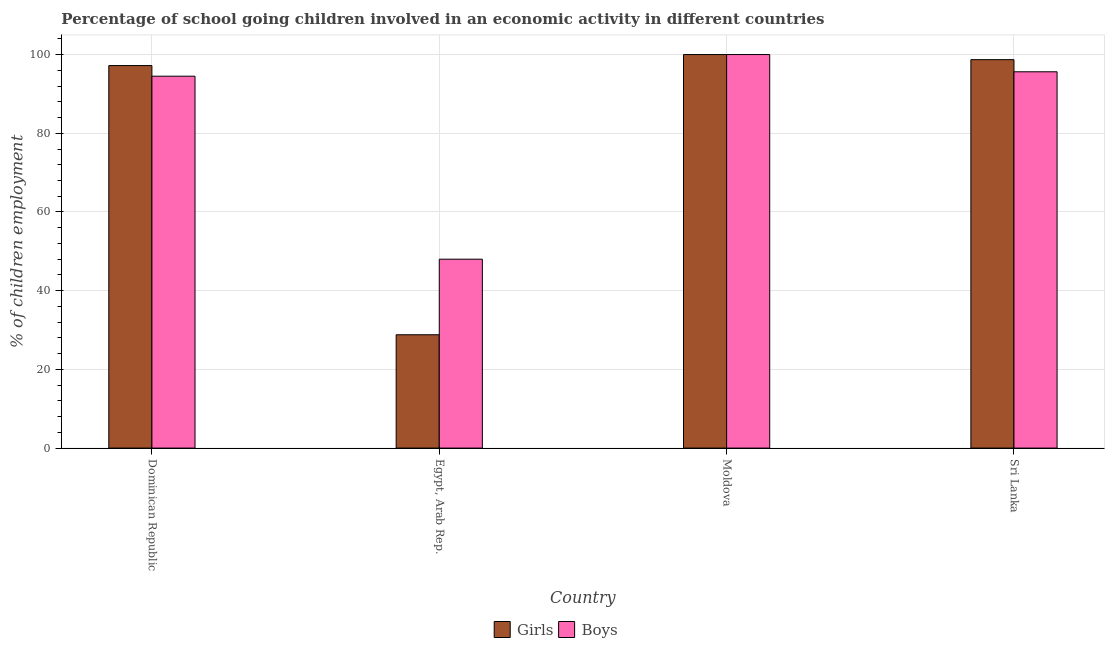How many different coloured bars are there?
Offer a very short reply. 2. How many bars are there on the 2nd tick from the left?
Offer a terse response. 2. What is the label of the 1st group of bars from the left?
Offer a terse response. Dominican Republic. Across all countries, what is the maximum percentage of school going boys?
Provide a short and direct response. 100. In which country was the percentage of school going boys maximum?
Your answer should be very brief. Moldova. In which country was the percentage of school going boys minimum?
Give a very brief answer. Egypt, Arab Rep. What is the total percentage of school going boys in the graph?
Your response must be concise. 338.12. What is the difference between the percentage of school going boys in Egypt, Arab Rep. and that in Sri Lanka?
Give a very brief answer. -47.62. What is the difference between the percentage of school going boys in Sri Lanka and the percentage of school going girls in Dominican Republic?
Make the answer very short. -1.58. What is the average percentage of school going girls per country?
Provide a succinct answer. 81.18. What is the difference between the percentage of school going girls and percentage of school going boys in Sri Lanka?
Ensure brevity in your answer.  3.08. In how many countries, is the percentage of school going boys greater than 4 %?
Ensure brevity in your answer.  4. What is the ratio of the percentage of school going girls in Dominican Republic to that in Moldova?
Provide a short and direct response. 0.97. What is the difference between the highest and the second highest percentage of school going girls?
Offer a terse response. 1.29. What is the difference between the highest and the lowest percentage of school going girls?
Keep it short and to the point. 71.2. Is the sum of the percentage of school going boys in Moldova and Sri Lanka greater than the maximum percentage of school going girls across all countries?
Your answer should be compact. Yes. What does the 1st bar from the left in Egypt, Arab Rep. represents?
Ensure brevity in your answer.  Girls. What does the 1st bar from the right in Dominican Republic represents?
Ensure brevity in your answer.  Boys. Are all the bars in the graph horizontal?
Offer a very short reply. No. How are the legend labels stacked?
Provide a short and direct response. Horizontal. What is the title of the graph?
Your answer should be very brief. Percentage of school going children involved in an economic activity in different countries. What is the label or title of the Y-axis?
Make the answer very short. % of children employment. What is the % of children employment of Girls in Dominican Republic?
Keep it short and to the point. 97.2. What is the % of children employment in Boys in Dominican Republic?
Your answer should be very brief. 94.5. What is the % of children employment of Girls in Egypt, Arab Rep.?
Keep it short and to the point. 28.8. What is the % of children employment in Boys in Egypt, Arab Rep.?
Ensure brevity in your answer.  48. What is the % of children employment in Girls in Sri Lanka?
Provide a short and direct response. 98.71. What is the % of children employment in Boys in Sri Lanka?
Give a very brief answer. 95.62. Across all countries, what is the minimum % of children employment in Girls?
Keep it short and to the point. 28.8. Across all countries, what is the minimum % of children employment in Boys?
Make the answer very short. 48. What is the total % of children employment of Girls in the graph?
Your answer should be very brief. 324.7. What is the total % of children employment of Boys in the graph?
Your response must be concise. 338.12. What is the difference between the % of children employment of Girls in Dominican Republic and that in Egypt, Arab Rep.?
Provide a succinct answer. 68.4. What is the difference between the % of children employment in Boys in Dominican Republic and that in Egypt, Arab Rep.?
Offer a very short reply. 46.5. What is the difference between the % of children employment in Girls in Dominican Republic and that in Moldova?
Give a very brief answer. -2.8. What is the difference between the % of children employment of Girls in Dominican Republic and that in Sri Lanka?
Your response must be concise. -1.5. What is the difference between the % of children employment of Boys in Dominican Republic and that in Sri Lanka?
Provide a short and direct response. -1.12. What is the difference between the % of children employment of Girls in Egypt, Arab Rep. and that in Moldova?
Provide a short and direct response. -71.2. What is the difference between the % of children employment of Boys in Egypt, Arab Rep. and that in Moldova?
Offer a terse response. -52. What is the difference between the % of children employment of Girls in Egypt, Arab Rep. and that in Sri Lanka?
Your answer should be compact. -69.91. What is the difference between the % of children employment of Boys in Egypt, Arab Rep. and that in Sri Lanka?
Ensure brevity in your answer.  -47.62. What is the difference between the % of children employment of Girls in Moldova and that in Sri Lanka?
Give a very brief answer. 1.29. What is the difference between the % of children employment in Boys in Moldova and that in Sri Lanka?
Provide a succinct answer. 4.38. What is the difference between the % of children employment of Girls in Dominican Republic and the % of children employment of Boys in Egypt, Arab Rep.?
Your answer should be very brief. 49.2. What is the difference between the % of children employment in Girls in Dominican Republic and the % of children employment in Boys in Moldova?
Your answer should be compact. -2.8. What is the difference between the % of children employment in Girls in Dominican Republic and the % of children employment in Boys in Sri Lanka?
Offer a terse response. 1.58. What is the difference between the % of children employment in Girls in Egypt, Arab Rep. and the % of children employment in Boys in Moldova?
Give a very brief answer. -71.2. What is the difference between the % of children employment of Girls in Egypt, Arab Rep. and the % of children employment of Boys in Sri Lanka?
Offer a very short reply. -66.82. What is the difference between the % of children employment in Girls in Moldova and the % of children employment in Boys in Sri Lanka?
Make the answer very short. 4.38. What is the average % of children employment of Girls per country?
Provide a succinct answer. 81.18. What is the average % of children employment of Boys per country?
Provide a short and direct response. 84.53. What is the difference between the % of children employment of Girls and % of children employment of Boys in Dominican Republic?
Provide a succinct answer. 2.7. What is the difference between the % of children employment of Girls and % of children employment of Boys in Egypt, Arab Rep.?
Ensure brevity in your answer.  -19.2. What is the difference between the % of children employment in Girls and % of children employment in Boys in Moldova?
Give a very brief answer. 0. What is the difference between the % of children employment of Girls and % of children employment of Boys in Sri Lanka?
Your response must be concise. 3.08. What is the ratio of the % of children employment of Girls in Dominican Republic to that in Egypt, Arab Rep.?
Your answer should be compact. 3.38. What is the ratio of the % of children employment of Boys in Dominican Republic to that in Egypt, Arab Rep.?
Offer a terse response. 1.97. What is the ratio of the % of children employment in Boys in Dominican Republic to that in Moldova?
Make the answer very short. 0.94. What is the ratio of the % of children employment of Boys in Dominican Republic to that in Sri Lanka?
Your answer should be compact. 0.99. What is the ratio of the % of children employment in Girls in Egypt, Arab Rep. to that in Moldova?
Provide a succinct answer. 0.29. What is the ratio of the % of children employment of Boys in Egypt, Arab Rep. to that in Moldova?
Ensure brevity in your answer.  0.48. What is the ratio of the % of children employment of Girls in Egypt, Arab Rep. to that in Sri Lanka?
Give a very brief answer. 0.29. What is the ratio of the % of children employment in Boys in Egypt, Arab Rep. to that in Sri Lanka?
Keep it short and to the point. 0.5. What is the ratio of the % of children employment in Girls in Moldova to that in Sri Lanka?
Your answer should be compact. 1.01. What is the ratio of the % of children employment of Boys in Moldova to that in Sri Lanka?
Your answer should be very brief. 1.05. What is the difference between the highest and the second highest % of children employment of Girls?
Ensure brevity in your answer.  1.29. What is the difference between the highest and the second highest % of children employment of Boys?
Provide a succinct answer. 4.38. What is the difference between the highest and the lowest % of children employment of Girls?
Provide a short and direct response. 71.2. 